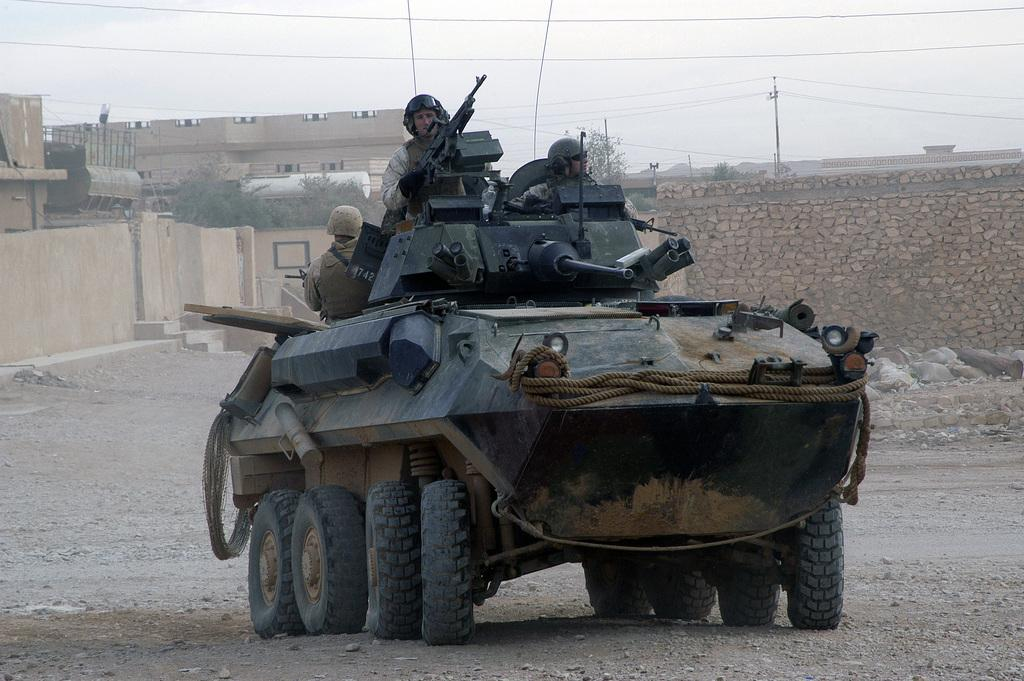What are the persons in the image riding on? The persons in the image are on an armored vehicle. What can be seen in the background of the image? There are buildings and trees in the background of the image. What is visible at the top of the image? The sky is visible at the top of the image. How many ducks are swimming in the water near the armored vehicle in the image? There are no ducks present in the image. 